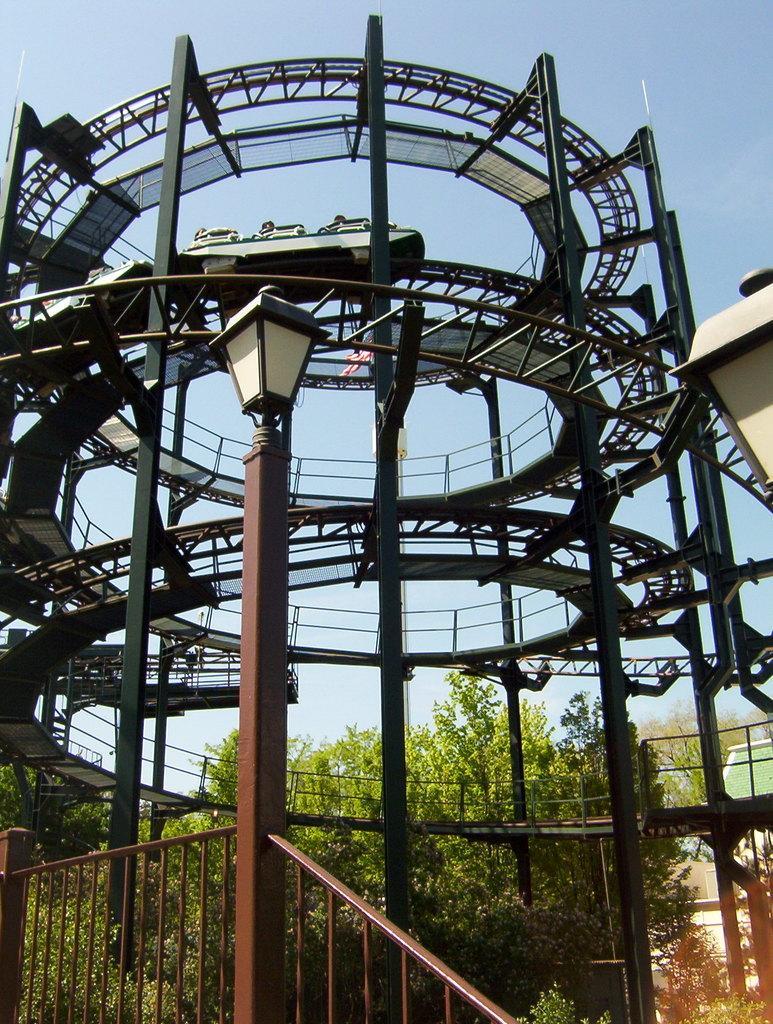Can you describe this image briefly? In this picture we can see a pole with light and behind the pole there are trees, an architecture tower and a sky. 